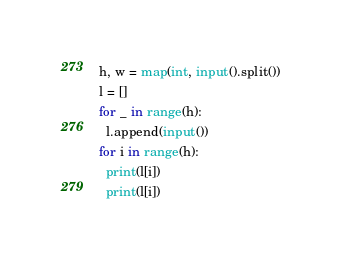<code> <loc_0><loc_0><loc_500><loc_500><_Python_>h, w = map(int, input().split())
l = []
for _ in range(h):
  l.append(input())
for i in range(h):
  print(l[i])
  print(l[i])</code> 